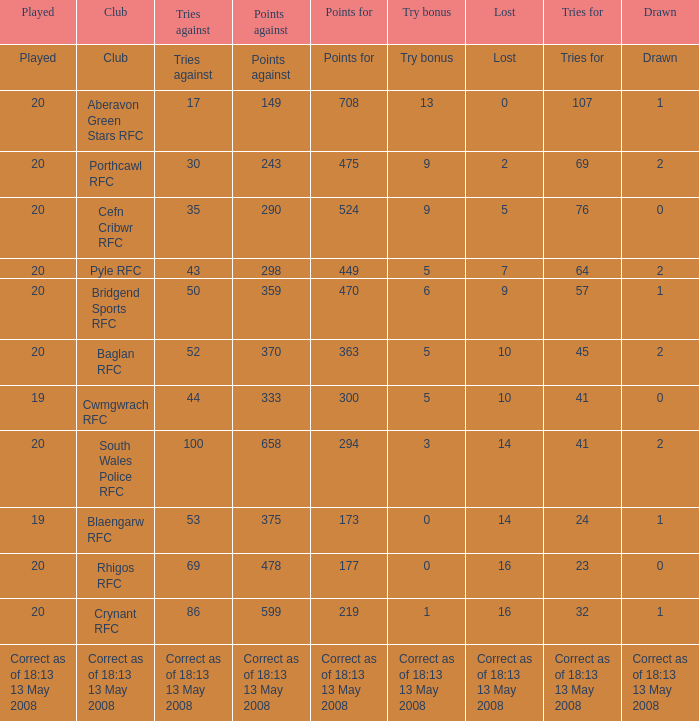What is the points number when 20 shows for played, and lost is 0? 708.0. 